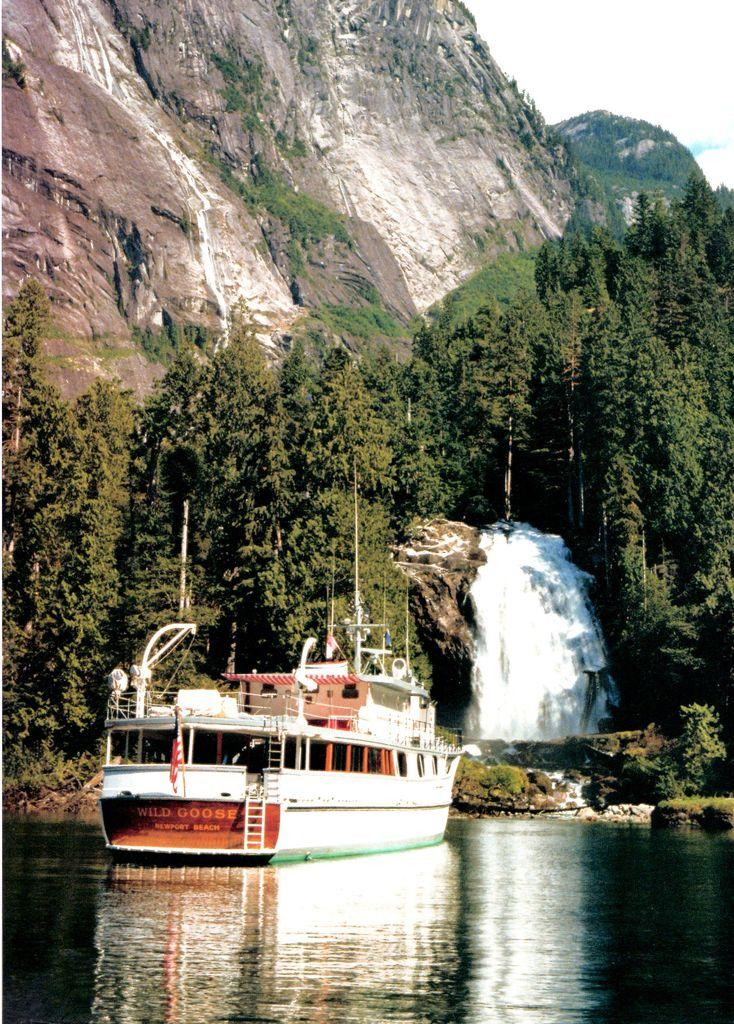What is the main subject of the image? The main subject of the image is a ship. Where is the ship located? The ship is on a river. What can be seen in the background of the image? There are trees, a waterfall, mountains, and the sky visible in the background of the image. What type of birds can be seen flying over the ship in the image? There are no birds visible in the image; it only features a ship on a river with a background of trees, a waterfall, mountains, and the sky. 